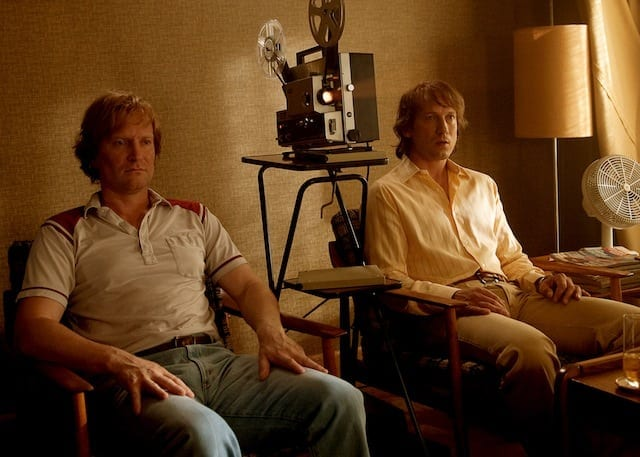If this image were a scene from a movie, what might it symbolize? This image could symbolize a moment of deep reflection and connection between the characters. The vintage setting suggests themes of nostalgia and the passage of time. The film projector in the background might represent the memories or stories of the past that they are revisiting. The casual attire and relaxed postures of the men indicate a sense of comfort and trust in each other's company, potentially highlighting the theme of enduring friendship. Imagine this image as part of a historical documentary. What could be the documentary's focus? The documentary could focus on the evolution of cinema and its impact on small-town communities. It could delve into how local cinemas served as cultural hubs, bringing people together and fostering a shared love for movies. Featuring people like Jack and Martin, who devoted their lives to the preservation and promotion of film, the documentary would explore personal stories, the significance of film in shaping personal and collective identities, and the nostalgic charm of vintage cinematic technology. 